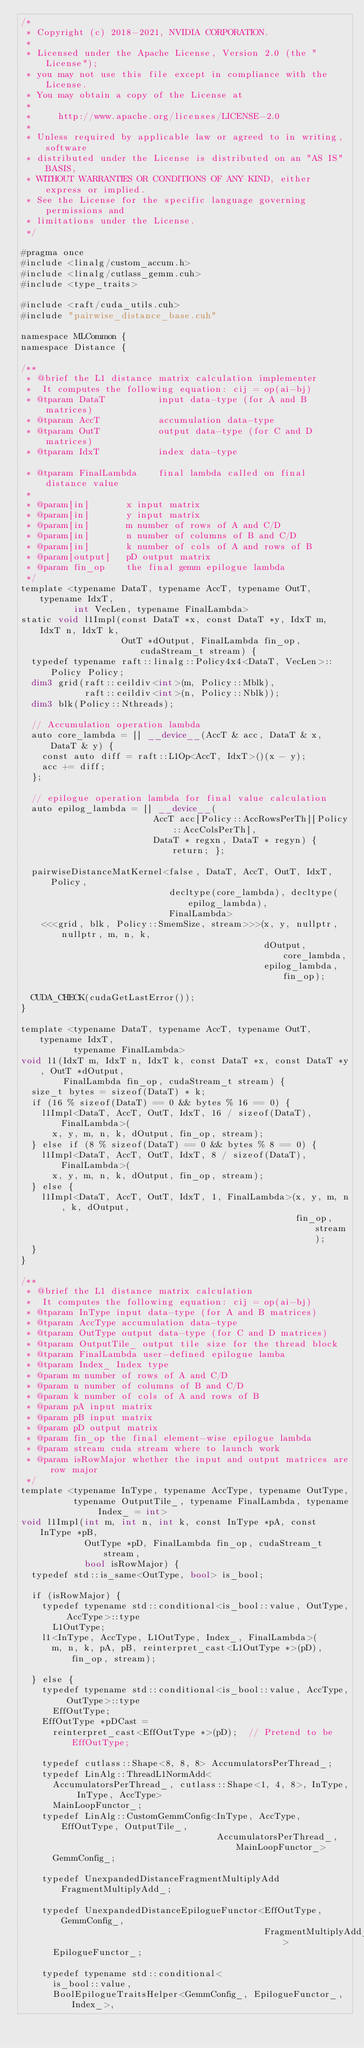Convert code to text. <code><loc_0><loc_0><loc_500><loc_500><_Cuda_>/*
 * Copyright (c) 2018-2021, NVIDIA CORPORATION.
 *
 * Licensed under the Apache License, Version 2.0 (the "License");
 * you may not use this file except in compliance with the License.
 * You may obtain a copy of the License at
 *
 *     http://www.apache.org/licenses/LICENSE-2.0
 *
 * Unless required by applicable law or agreed to in writing, software
 * distributed under the License is distributed on an "AS IS" BASIS,
 * WITHOUT WARRANTIES OR CONDITIONS OF ANY KIND, either express or implied.
 * See the License for the specific language governing permissions and
 * limitations under the License.
 */

#pragma once
#include <linalg/custom_accum.h>
#include <linalg/cutlass_gemm.cuh>
#include <type_traits>

#include <raft/cuda_utils.cuh>
#include "pairwise_distance_base.cuh"

namespace MLCommon {
namespace Distance {

/**
 * @brief the L1 distance matrix calculation implementer
 *  It computes the following equation: cij = op(ai-bj)
 * @tparam DataT          input data-type (for A and B matrices)
 * @tparam AccT           accumulation data-type
 * @tparam OutT           output data-type (for C and D matrices)
 * @tparam IdxT           index data-type

 * @tparam FinalLambda    final lambda called on final distance value
 *
 * @param[in]       x input matrix
 * @param[in]       y input matrix
 * @param[in]       m number of rows of A and C/D
 * @param[in]       n number of columns of B and C/D
 * @param[in]       k number of cols of A and rows of B
 * @param[output]   pD output matrix
 * @param fin_op    the final gemm epilogue lambda
 */
template <typename DataT, typename AccT, typename OutT, typename IdxT,
          int VecLen, typename FinalLambda>
static void l1Impl(const DataT *x, const DataT *y, IdxT m, IdxT n, IdxT k,
                   OutT *dOutput, FinalLambda fin_op, cudaStream_t stream) {
  typedef typename raft::linalg::Policy4x4<DataT, VecLen>::Policy Policy;
  dim3 grid(raft::ceildiv<int>(m, Policy::Mblk),
            raft::ceildiv<int>(n, Policy::Nblk));
  dim3 blk(Policy::Nthreads);

  // Accumulation operation lambda
  auto core_lambda = [] __device__(AccT & acc, DataT & x, DataT & y) {
    const auto diff = raft::L1Op<AccT, IdxT>()(x - y);
    acc += diff;
  };

  // epilogue operation lambda for final value calculation
  auto epilog_lambda = [] __device__(
                         AccT acc[Policy::AccRowsPerTh][Policy::AccColsPerTh],
                         DataT * regxn, DataT * regyn) { return; };

  pairwiseDistanceMatKernel<false, DataT, AccT, OutT, IdxT, Policy,
                            decltype(core_lambda), decltype(epilog_lambda),
                            FinalLambda>
    <<<grid, blk, Policy::SmemSize, stream>>>(x, y, nullptr, nullptr, m, n, k,
                                              dOutput, core_lambda,
                                              epilog_lambda, fin_op);

  CUDA_CHECK(cudaGetLastError());
}

template <typename DataT, typename AccT, typename OutT, typename IdxT,
          typename FinalLambda>
void l1(IdxT m, IdxT n, IdxT k, const DataT *x, const DataT *y, OutT *dOutput,
        FinalLambda fin_op, cudaStream_t stream) {
  size_t bytes = sizeof(DataT) * k;
  if (16 % sizeof(DataT) == 0 && bytes % 16 == 0) {
    l1Impl<DataT, AccT, OutT, IdxT, 16 / sizeof(DataT), FinalLambda>(
      x, y, m, n, k, dOutput, fin_op, stream);
  } else if (8 % sizeof(DataT) == 0 && bytes % 8 == 0) {
    l1Impl<DataT, AccT, OutT, IdxT, 8 / sizeof(DataT), FinalLambda>(
      x, y, m, n, k, dOutput, fin_op, stream);
  } else {
    l1Impl<DataT, AccT, OutT, IdxT, 1, FinalLambda>(x, y, m, n, k, dOutput,
                                                    fin_op, stream);
  }
}

/**
 * @brief the L1 distance matrix calculation
 *  It computes the following equation: cij = op(ai-bj)
 * @tparam InType input data-type (for A and B matrices)
 * @tparam AccType accumulation data-type
 * @tparam OutType output data-type (for C and D matrices)
 * @tparam OutputTile_ output tile size for the thread block
 * @tparam FinalLambda user-defined epilogue lamba
 * @tparam Index_ Index type
 * @param m number of rows of A and C/D
 * @param n number of columns of B and C/D
 * @param k number of cols of A and rows of B
 * @param pA input matrix
 * @param pB input matrix
 * @param pD output matrix
 * @param fin_op the final element-wise epilogue lambda
 * @param stream cuda stream where to launch work
 * @param isRowMajor whether the input and output matrices are row major
 */
template <typename InType, typename AccType, typename OutType,
          typename OutputTile_, typename FinalLambda, typename Index_ = int>
void l1Impl(int m, int n, int k, const InType *pA, const InType *pB,
            OutType *pD, FinalLambda fin_op, cudaStream_t stream,
            bool isRowMajor) {
  typedef std::is_same<OutType, bool> is_bool;

  if (isRowMajor) {
    typedef typename std::conditional<is_bool::value, OutType, AccType>::type
      L1OutType;
    l1<InType, AccType, L1OutType, Index_, FinalLambda>(
      m, n, k, pA, pB, reinterpret_cast<L1OutType *>(pD), fin_op, stream);

  } else {
    typedef typename std::conditional<is_bool::value, AccType, OutType>::type
      EffOutType;
    EffOutType *pDCast =
      reinterpret_cast<EffOutType *>(pD);  // Pretend to be EffOutType;

    typedef cutlass::Shape<8, 8, 8> AccumulatorsPerThread_;
    typedef LinAlg::ThreadL1NormAdd<
      AccumulatorsPerThread_, cutlass::Shape<1, 4, 8>, InType, InType, AccType>
      MainLoopFunctor_;
    typedef LinAlg::CustomGemmConfig<InType, AccType, EffOutType, OutputTile_,
                                     AccumulatorsPerThread_, MainLoopFunctor_>
      GemmConfig_;

    typedef UnexpandedDistanceFragmentMultiplyAdd FragmentMultiplyAdd_;

    typedef UnexpandedDistanceEpilogueFunctor<EffOutType, GemmConfig_,
                                              FragmentMultiplyAdd_>
      EpilogueFunctor_;

    typedef typename std::conditional<
      is_bool::value,
      BoolEpilogueTraitsHelper<GemmConfig_, EpilogueFunctor_, Index_>,</code> 